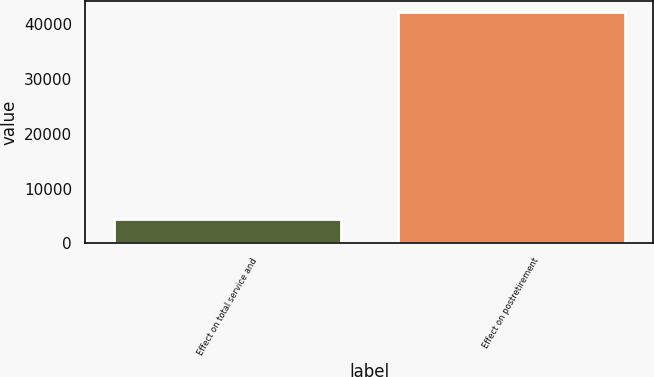Convert chart to OTSL. <chart><loc_0><loc_0><loc_500><loc_500><bar_chart><fcel>Effect on total service and<fcel>Effect on postretirement<nl><fcel>4539<fcel>42079<nl></chart> 